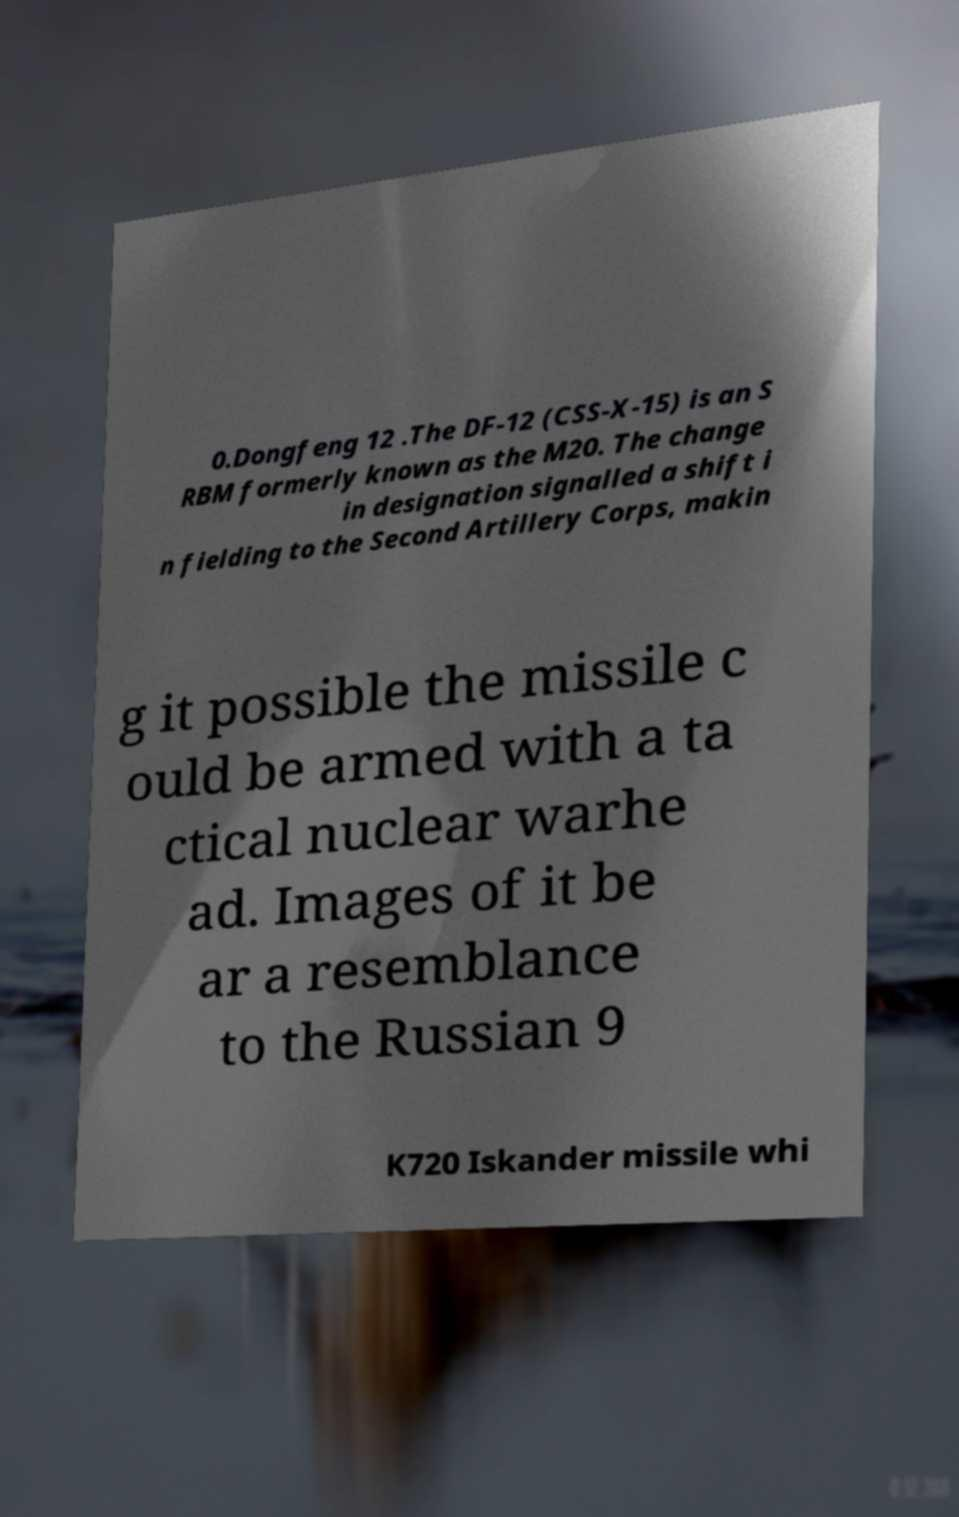What messages or text are displayed in this image? I need them in a readable, typed format. 0.Dongfeng 12 .The DF-12 (CSS-X-15) is an S RBM formerly known as the M20. The change in designation signalled a shift i n fielding to the Second Artillery Corps, makin g it possible the missile c ould be armed with a ta ctical nuclear warhe ad. Images of it be ar a resemblance to the Russian 9 K720 Iskander missile whi 